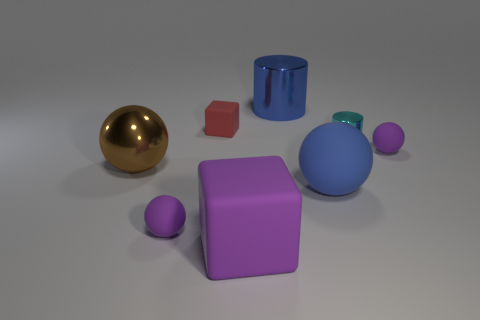Subtract all brown metal balls. How many balls are left? 3 Add 1 green matte cylinders. How many objects exist? 9 Subtract all blue spheres. How many spheres are left? 3 Subtract 3 spheres. How many spheres are left? 1 Subtract all cylinders. How many objects are left? 6 Subtract all red cylinders. Subtract all brown spheres. How many cylinders are left? 2 Subtract all cyan cylinders. How many cyan blocks are left? 0 Subtract all green metallic things. Subtract all purple spheres. How many objects are left? 6 Add 6 shiny balls. How many shiny balls are left? 7 Add 1 gray matte spheres. How many gray matte spheres exist? 1 